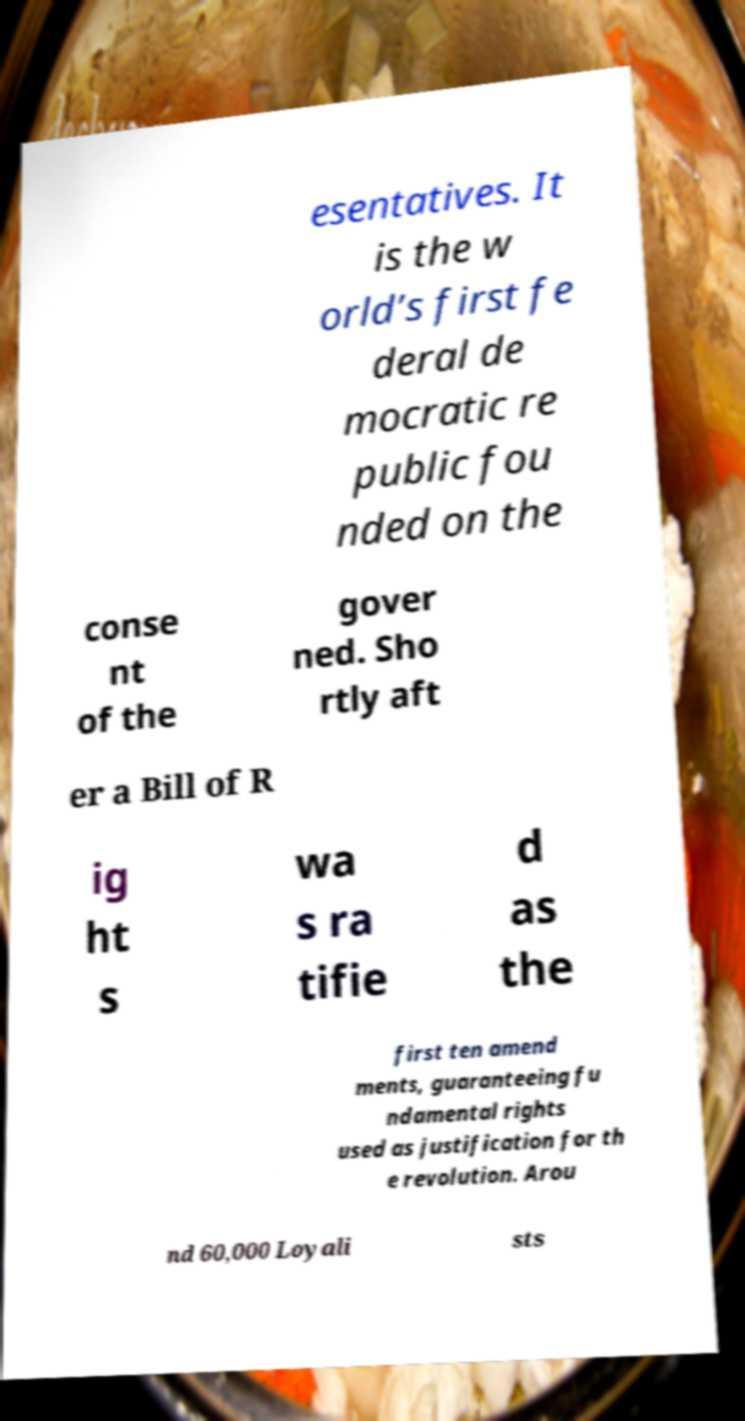I need the written content from this picture converted into text. Can you do that? esentatives. It is the w orld’s first fe deral de mocratic re public fou nded on the conse nt of the gover ned. Sho rtly aft er a Bill of R ig ht s wa s ra tifie d as the first ten amend ments, guaranteeing fu ndamental rights used as justification for th e revolution. Arou nd 60,000 Loyali sts 